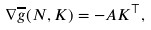Convert formula to latex. <formula><loc_0><loc_0><loc_500><loc_500>\nabla \overline { g } ( N , K ) = - A K ^ { \top } ,</formula> 